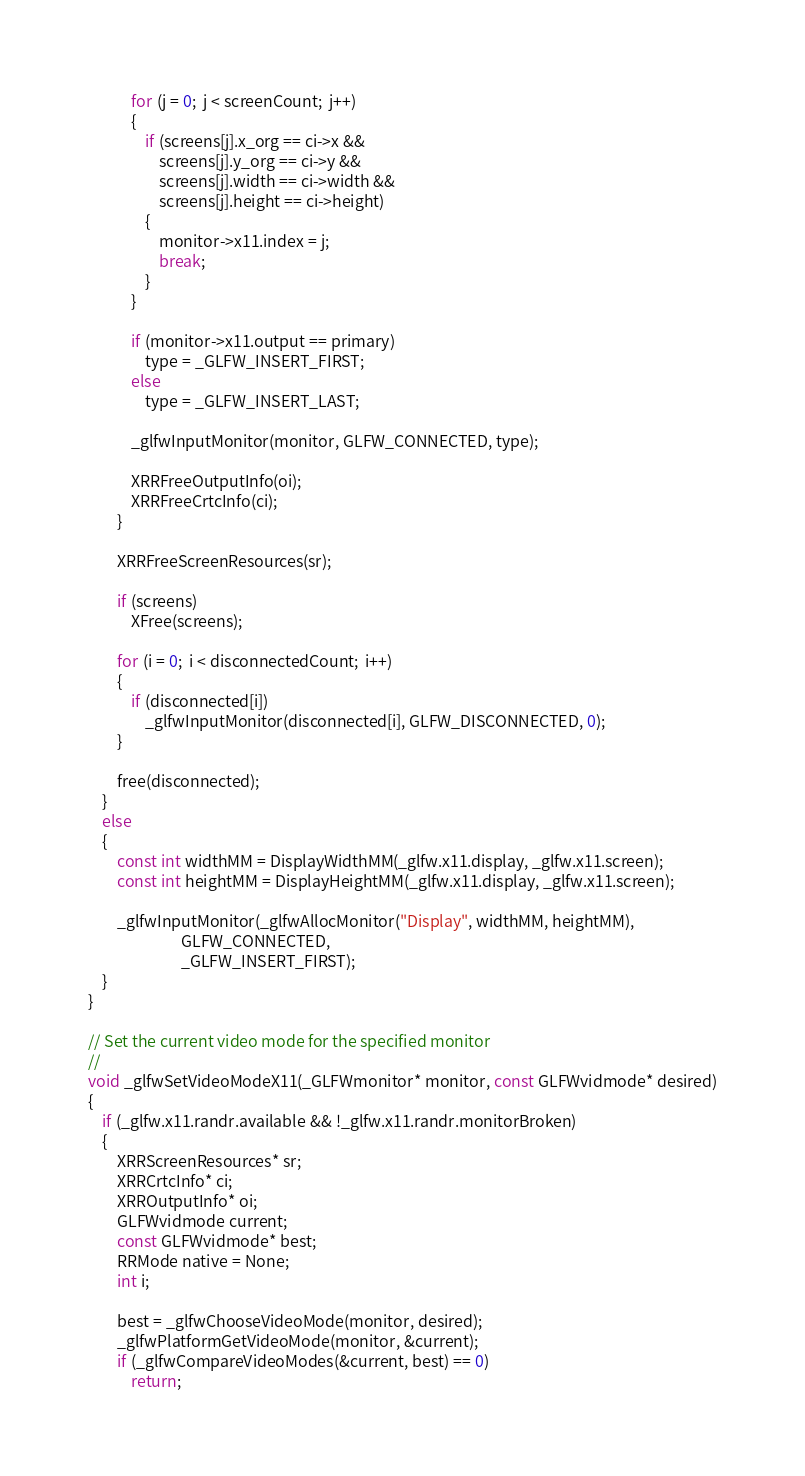Convert code to text. <code><loc_0><loc_0><loc_500><loc_500><_C_>            for (j = 0;  j < screenCount;  j++)
            {
                if (screens[j].x_org == ci->x &&
                    screens[j].y_org == ci->y &&
                    screens[j].width == ci->width &&
                    screens[j].height == ci->height)
                {
                    monitor->x11.index = j;
                    break;
                }
            }

            if (monitor->x11.output == primary)
                type = _GLFW_INSERT_FIRST;
            else
                type = _GLFW_INSERT_LAST;

            _glfwInputMonitor(monitor, GLFW_CONNECTED, type);

            XRRFreeOutputInfo(oi);
            XRRFreeCrtcInfo(ci);
        }

        XRRFreeScreenResources(sr);

        if (screens)
            XFree(screens);

        for (i = 0;  i < disconnectedCount;  i++)
        {
            if (disconnected[i])
                _glfwInputMonitor(disconnected[i], GLFW_DISCONNECTED, 0);
        }

        free(disconnected);
    }
    else
    {
        const int widthMM = DisplayWidthMM(_glfw.x11.display, _glfw.x11.screen);
        const int heightMM = DisplayHeightMM(_glfw.x11.display, _glfw.x11.screen);

        _glfwInputMonitor(_glfwAllocMonitor("Display", widthMM, heightMM),
                          GLFW_CONNECTED,
                          _GLFW_INSERT_FIRST);
    }
}

// Set the current video mode for the specified monitor
//
void _glfwSetVideoModeX11(_GLFWmonitor* monitor, const GLFWvidmode* desired)
{
    if (_glfw.x11.randr.available && !_glfw.x11.randr.monitorBroken)
    {
        XRRScreenResources* sr;
        XRRCrtcInfo* ci;
        XRROutputInfo* oi;
        GLFWvidmode current;
        const GLFWvidmode* best;
        RRMode native = None;
        int i;

        best = _glfwChooseVideoMode(monitor, desired);
        _glfwPlatformGetVideoMode(monitor, &current);
        if (_glfwCompareVideoModes(&current, best) == 0)
            return;
</code> 